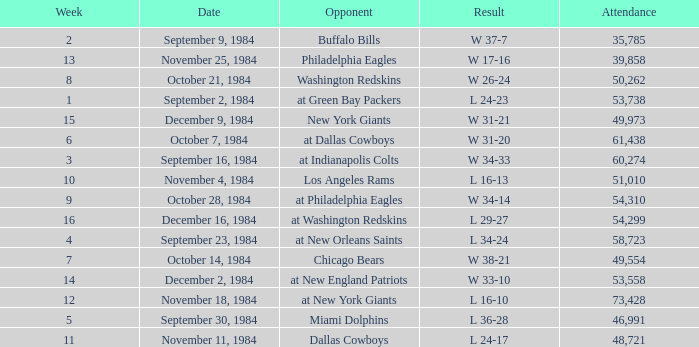What is the sum of attendance when the result was l 16-13? 51010.0. 